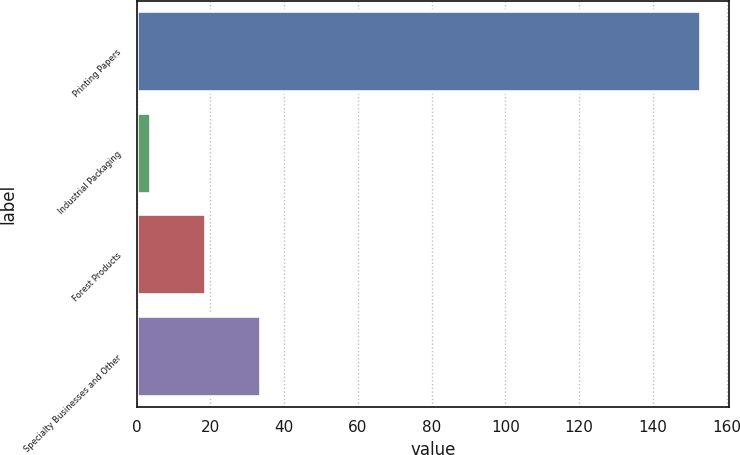<chart> <loc_0><loc_0><loc_500><loc_500><bar_chart><fcel>Printing Papers<fcel>Industrial Packaging<fcel>Forest Products<fcel>Specialty Businesses and Other<nl><fcel>153<fcel>4<fcel>18.9<fcel>33.8<nl></chart> 